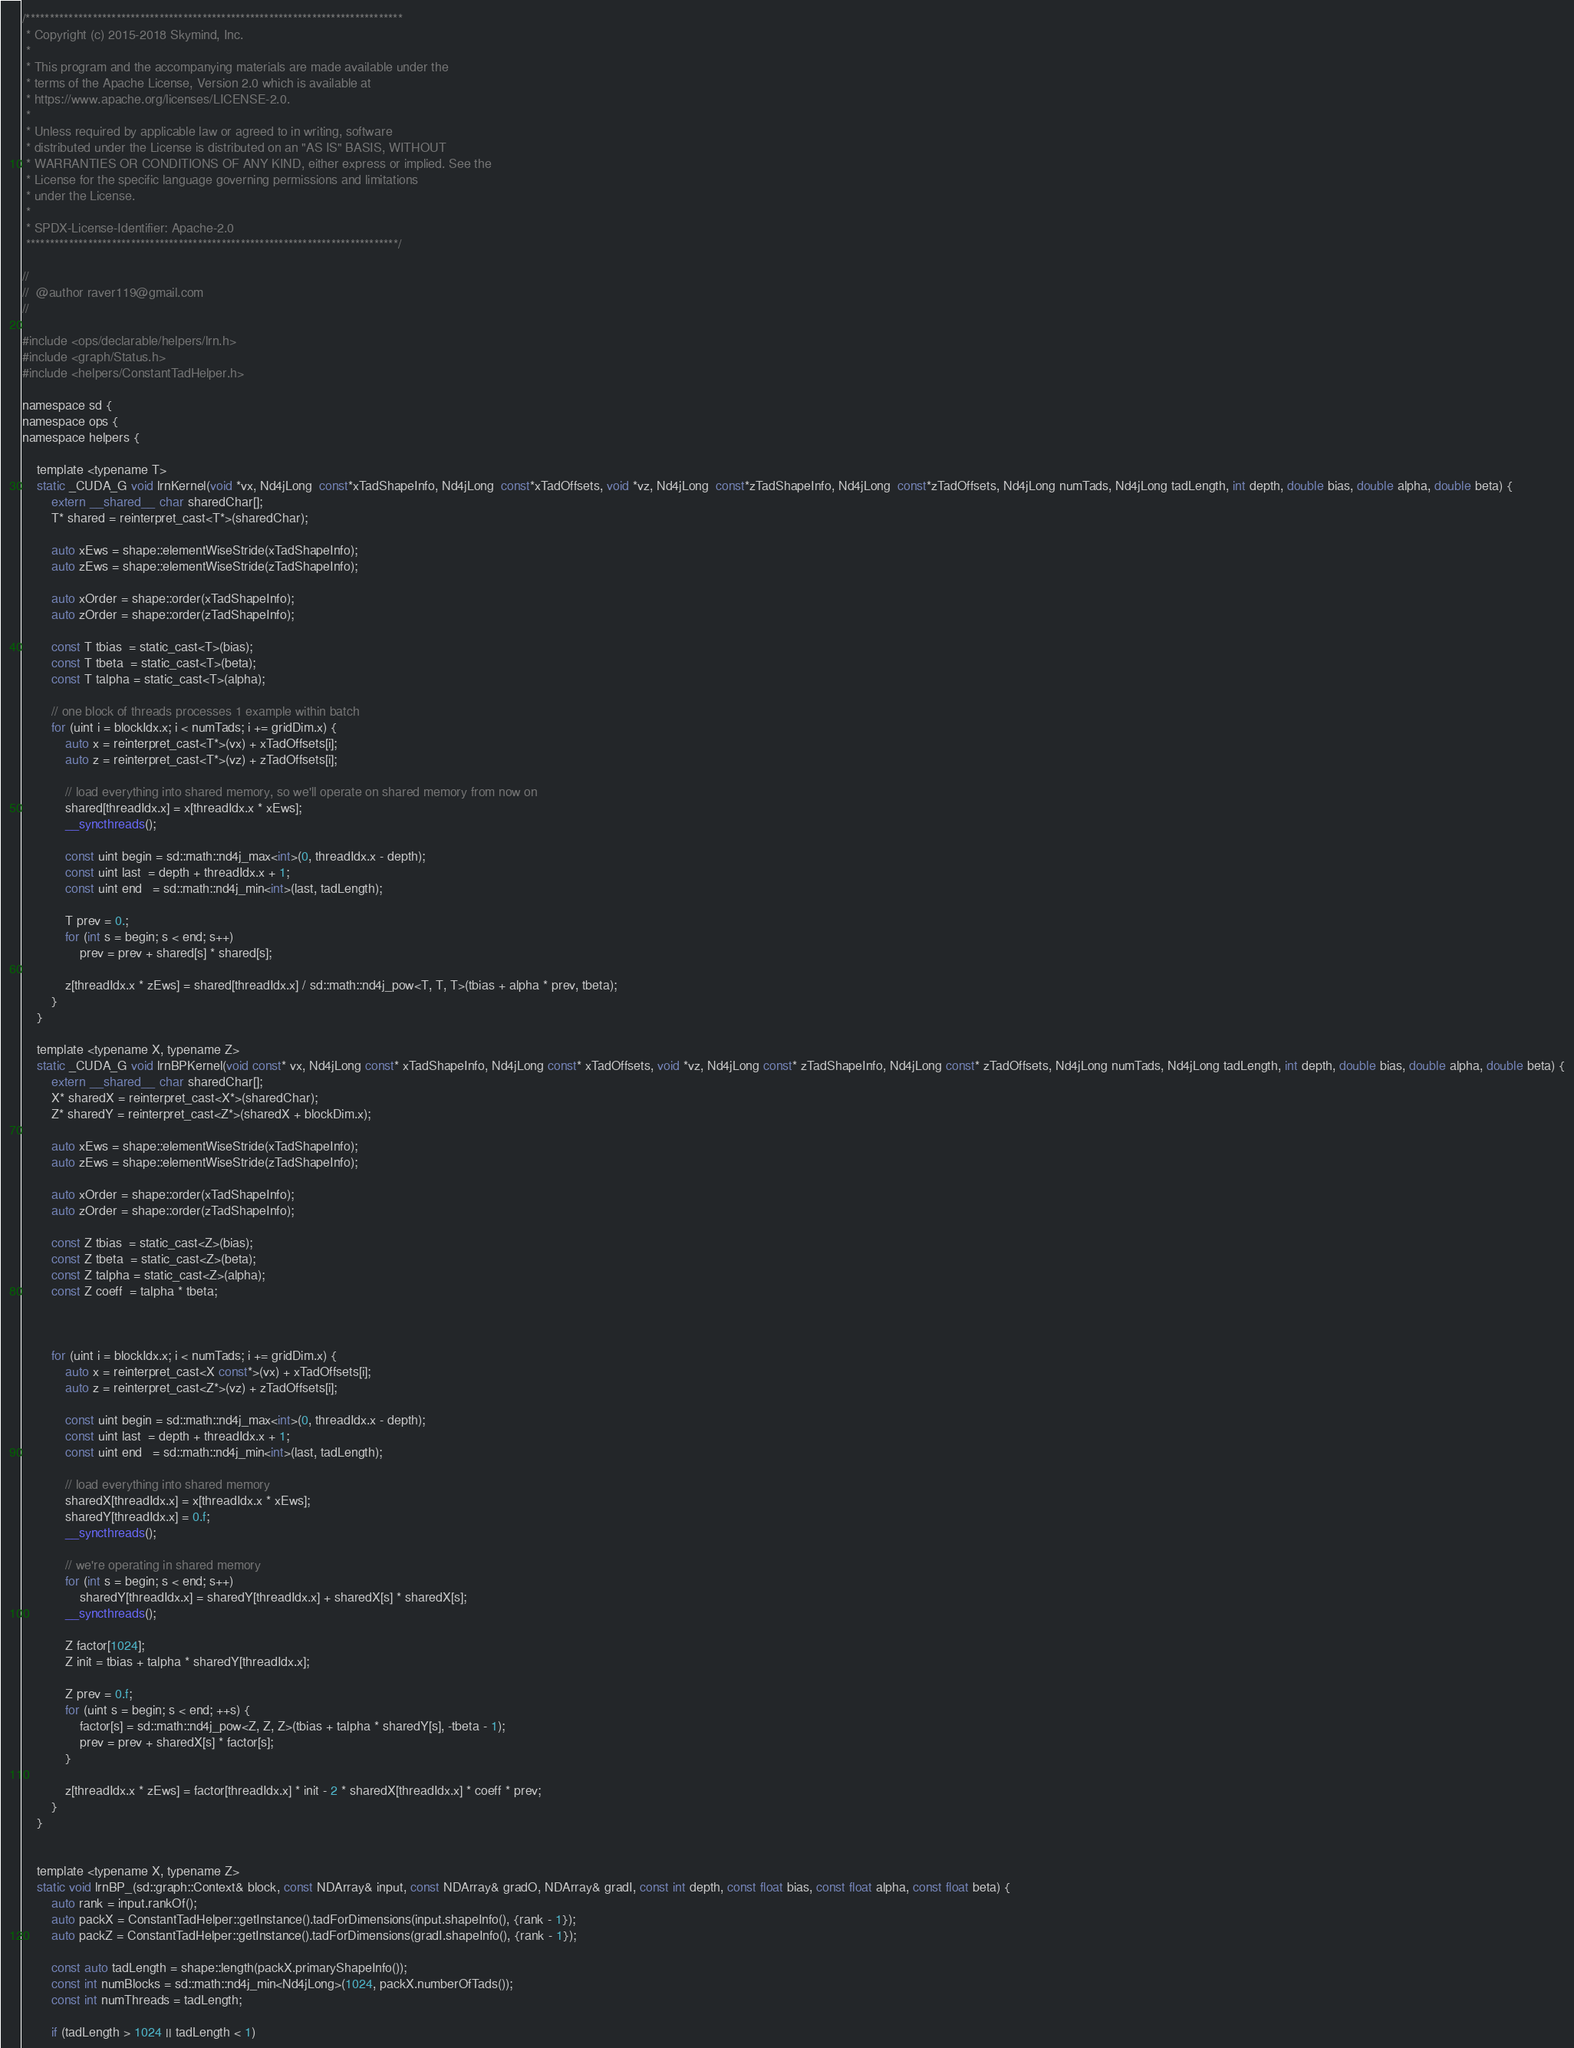<code> <loc_0><loc_0><loc_500><loc_500><_Cuda_>/*******************************************************************************
 * Copyright (c) 2015-2018 Skymind, Inc.
 *
 * This program and the accompanying materials are made available under the
 * terms of the Apache License, Version 2.0 which is available at
 * https://www.apache.org/licenses/LICENSE-2.0.
 *
 * Unless required by applicable law or agreed to in writing, software
 * distributed under the License is distributed on an "AS IS" BASIS, WITHOUT
 * WARRANTIES OR CONDITIONS OF ANY KIND, either express or implied. See the
 * License for the specific language governing permissions and limitations
 * under the License.
 *
 * SPDX-License-Identifier: Apache-2.0
 ******************************************************************************/

//
//  @author raver119@gmail.com
//

#include <ops/declarable/helpers/lrn.h>
#include <graph/Status.h>
#include <helpers/ConstantTadHelper.h>

namespace sd {
namespace ops {
namespace helpers {

    template <typename T>
    static _CUDA_G void lrnKernel(void *vx, Nd4jLong  const*xTadShapeInfo, Nd4jLong  const*xTadOffsets, void *vz, Nd4jLong  const*zTadShapeInfo, Nd4jLong  const*zTadOffsets, Nd4jLong numTads, Nd4jLong tadLength, int depth, double bias, double alpha, double beta) {
        extern __shared__ char sharedChar[];
        T* shared = reinterpret_cast<T*>(sharedChar);

        auto xEws = shape::elementWiseStride(xTadShapeInfo);
        auto zEws = shape::elementWiseStride(zTadShapeInfo);

        auto xOrder = shape::order(xTadShapeInfo);
        auto zOrder = shape::order(zTadShapeInfo);

        const T tbias  = static_cast<T>(bias);
        const T tbeta  = static_cast<T>(beta);
        const T talpha = static_cast<T>(alpha);

        // one block of threads processes 1 example within batch
        for (uint i = blockIdx.x; i < numTads; i += gridDim.x) {
            auto x = reinterpret_cast<T*>(vx) + xTadOffsets[i];
            auto z = reinterpret_cast<T*>(vz) + zTadOffsets[i];

            // load everything into shared memory, so we'll operate on shared memory from now on
            shared[threadIdx.x] = x[threadIdx.x * xEws];
            __syncthreads();

            const uint begin = sd::math::nd4j_max<int>(0, threadIdx.x - depth);
            const uint last  = depth + threadIdx.x + 1;
            const uint end   = sd::math::nd4j_min<int>(last, tadLength);

            T prev = 0.;
            for (int s = begin; s < end; s++)
                prev = prev + shared[s] * shared[s];

            z[threadIdx.x * zEws] = shared[threadIdx.x] / sd::math::nd4j_pow<T, T, T>(tbias + alpha * prev, tbeta);
        }
    }

    template <typename X, typename Z>
    static _CUDA_G void lrnBPKernel(void const* vx, Nd4jLong const* xTadShapeInfo, Nd4jLong const* xTadOffsets, void *vz, Nd4jLong const* zTadShapeInfo, Nd4jLong const* zTadOffsets, Nd4jLong numTads, Nd4jLong tadLength, int depth, double bias, double alpha, double beta) {
        extern __shared__ char sharedChar[];
        X* sharedX = reinterpret_cast<X*>(sharedChar);
        Z* sharedY = reinterpret_cast<Z*>(sharedX + blockDim.x);

        auto xEws = shape::elementWiseStride(xTadShapeInfo);
        auto zEws = shape::elementWiseStride(zTadShapeInfo);

        auto xOrder = shape::order(xTadShapeInfo);
        auto zOrder = shape::order(zTadShapeInfo);

        const Z tbias  = static_cast<Z>(bias);
        const Z tbeta  = static_cast<Z>(beta);
        const Z talpha = static_cast<Z>(alpha);
        const Z coeff  = talpha * tbeta;



        for (uint i = blockIdx.x; i < numTads; i += gridDim.x) {
            auto x = reinterpret_cast<X const*>(vx) + xTadOffsets[i];
            auto z = reinterpret_cast<Z*>(vz) + zTadOffsets[i];

            const uint begin = sd::math::nd4j_max<int>(0, threadIdx.x - depth);
            const uint last  = depth + threadIdx.x + 1;
            const uint end   = sd::math::nd4j_min<int>(last, tadLength);

            // load everything into shared memory
            sharedX[threadIdx.x] = x[threadIdx.x * xEws];
            sharedY[threadIdx.x] = 0.f;
            __syncthreads();

            // we're operating in shared memory
            for (int s = begin; s < end; s++)
                sharedY[threadIdx.x] = sharedY[threadIdx.x] + sharedX[s] * sharedX[s];
            __syncthreads();

            Z factor[1024];
            Z init = tbias + talpha * sharedY[threadIdx.x];

            Z prev = 0.f;
            for (uint s = begin; s < end; ++s) {
                factor[s] = sd::math::nd4j_pow<Z, Z, Z>(tbias + talpha * sharedY[s], -tbeta - 1);
                prev = prev + sharedX[s] * factor[s];
            }

            z[threadIdx.x * zEws] = factor[threadIdx.x] * init - 2 * sharedX[threadIdx.x] * coeff * prev;
        }
    }


    template <typename X, typename Z>
    static void lrnBP_(sd::graph::Context& block, const NDArray& input, const NDArray& gradO, NDArray& gradI, const int depth, const float bias, const float alpha, const float beta) {
        auto rank = input.rankOf();
        auto packX = ConstantTadHelper::getInstance().tadForDimensions(input.shapeInfo(), {rank - 1});
        auto packZ = ConstantTadHelper::getInstance().tadForDimensions(gradI.shapeInfo(), {rank - 1});

        const auto tadLength = shape::length(packX.primaryShapeInfo());
        const int numBlocks = sd::math::nd4j_min<Nd4jLong>(1024, packX.numberOfTads());
        const int numThreads = tadLength;

        if (tadLength > 1024 || tadLength < 1)</code> 